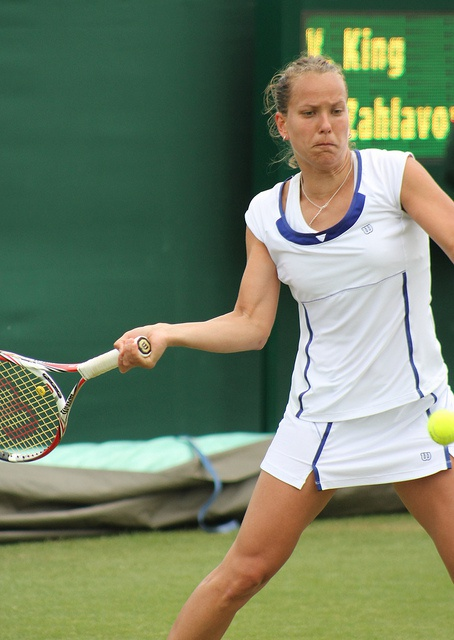Describe the objects in this image and their specific colors. I can see people in darkgreen, lightgray, tan, and salmon tones, tennis racket in darkgreen, teal, ivory, tan, and gray tones, and sports ball in darkgreen, yellow, and khaki tones in this image. 